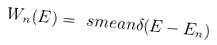Convert formula to latex. <formula><loc_0><loc_0><loc_500><loc_500>W _ { n } ( E ) = \ s m e a n { \delta ( E - E _ { n } ) }</formula> 